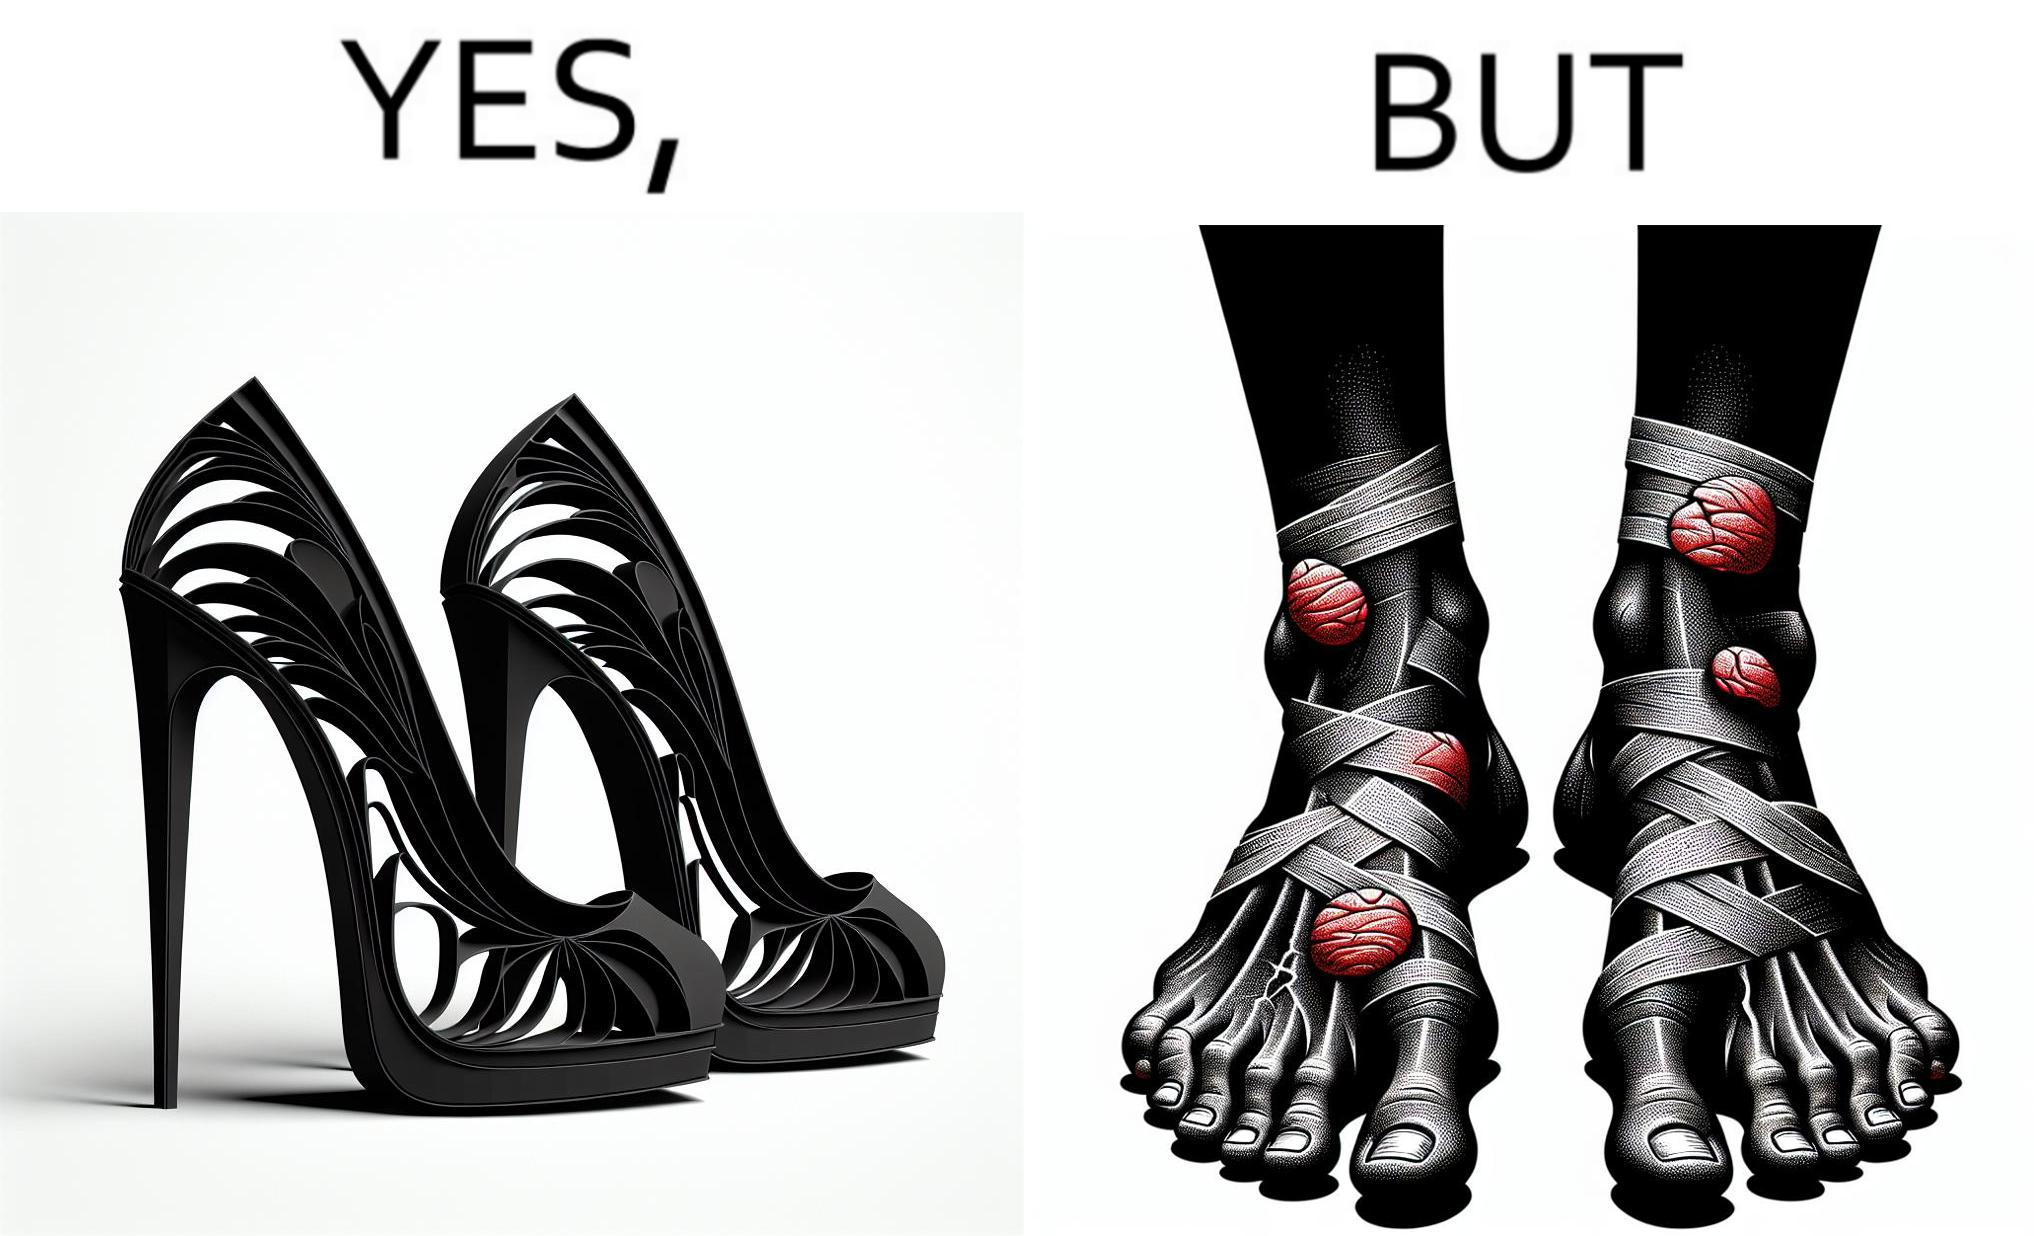Compare the left and right sides of this image. In the left part of the image: a pair of high heeled shoes In the right part of the image: A pair of feet, blistered and red, with bandages 